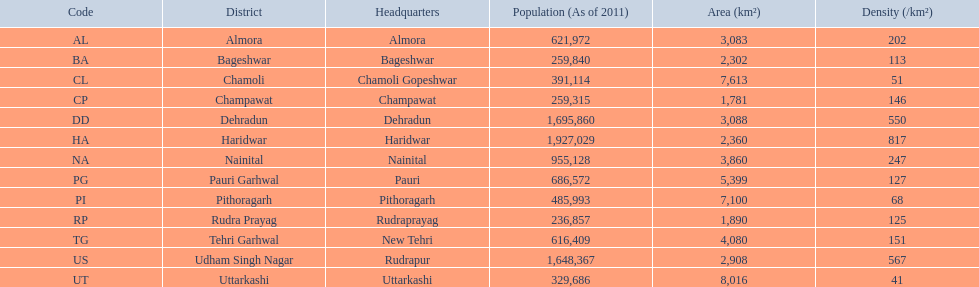Which district comes after haridwar in terms of population size? Dehradun. 